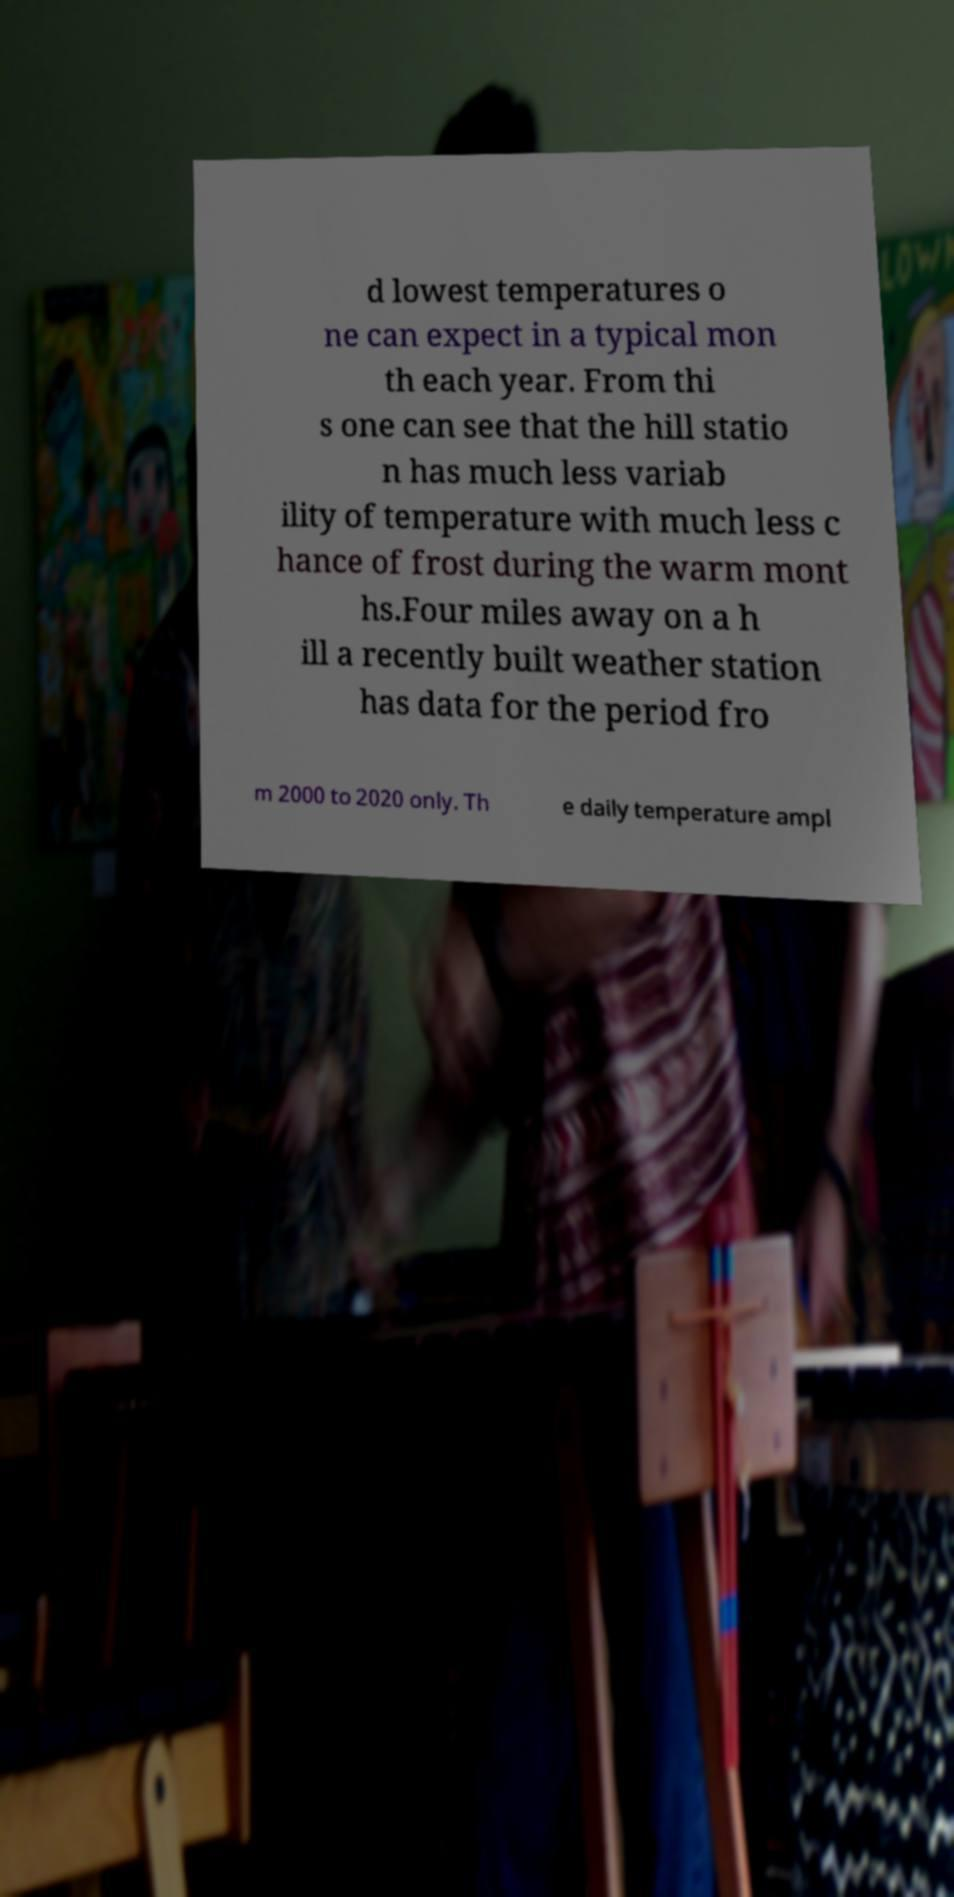What messages or text are displayed in this image? I need them in a readable, typed format. d lowest temperatures o ne can expect in a typical mon th each year. From thi s one can see that the hill statio n has much less variab ility of temperature with much less c hance of frost during the warm mont hs.Four miles away on a h ill a recently built weather station has data for the period fro m 2000 to 2020 only. Th e daily temperature ampl 